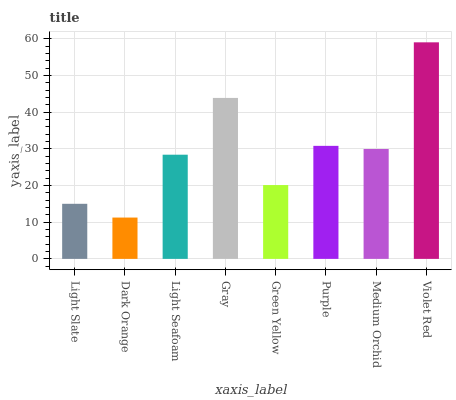Is Dark Orange the minimum?
Answer yes or no. Yes. Is Violet Red the maximum?
Answer yes or no. Yes. Is Light Seafoam the minimum?
Answer yes or no. No. Is Light Seafoam the maximum?
Answer yes or no. No. Is Light Seafoam greater than Dark Orange?
Answer yes or no. Yes. Is Dark Orange less than Light Seafoam?
Answer yes or no. Yes. Is Dark Orange greater than Light Seafoam?
Answer yes or no. No. Is Light Seafoam less than Dark Orange?
Answer yes or no. No. Is Medium Orchid the high median?
Answer yes or no. Yes. Is Light Seafoam the low median?
Answer yes or no. Yes. Is Light Slate the high median?
Answer yes or no. No. Is Purple the low median?
Answer yes or no. No. 